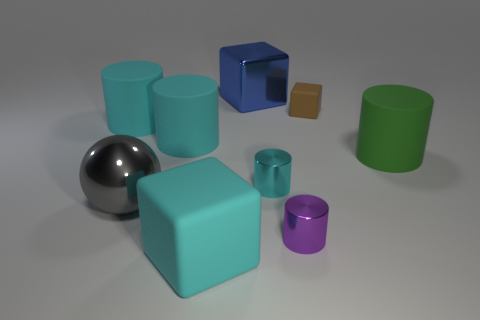How many cyan cylinders must be subtracted to get 1 cyan cylinders? 2 Subtract all blue spheres. How many cyan cylinders are left? 3 Subtract all purple cylinders. How many cylinders are left? 4 Subtract all small purple cylinders. How many cylinders are left? 4 Subtract 2 cylinders. How many cylinders are left? 3 Subtract all red cylinders. Subtract all blue spheres. How many cylinders are left? 5 Subtract all spheres. How many objects are left? 8 Subtract 1 purple cylinders. How many objects are left? 8 Subtract all blocks. Subtract all cyan cylinders. How many objects are left? 3 Add 8 blue metal blocks. How many blue metal blocks are left? 9 